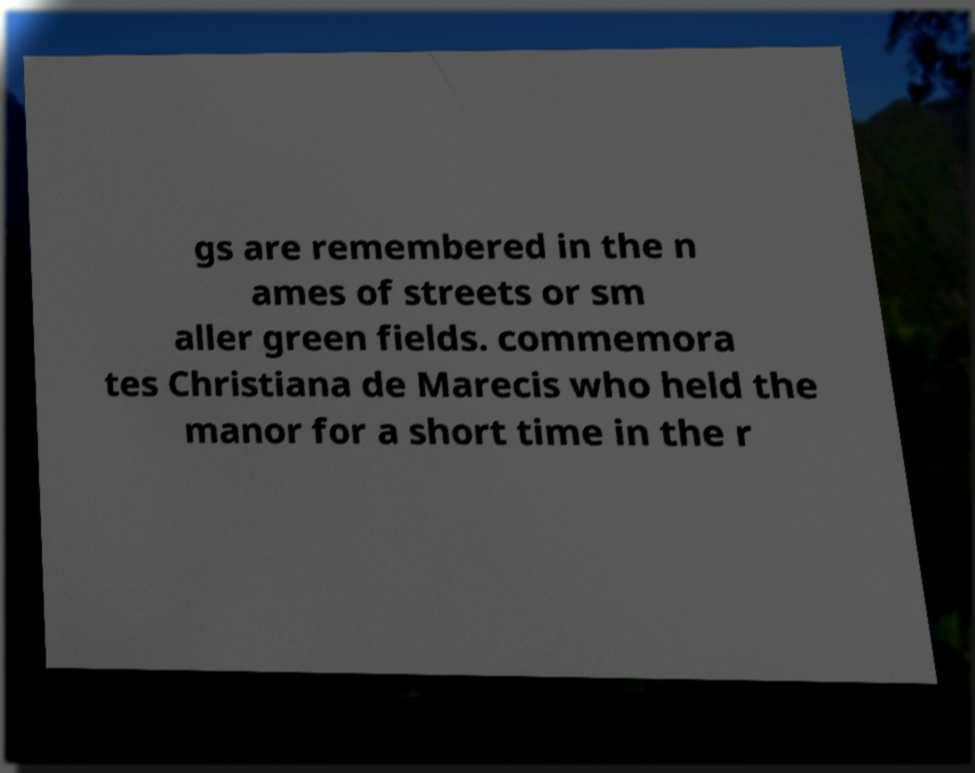There's text embedded in this image that I need extracted. Can you transcribe it verbatim? gs are remembered in the n ames of streets or sm aller green fields. commemora tes Christiana de Marecis who held the manor for a short time in the r 